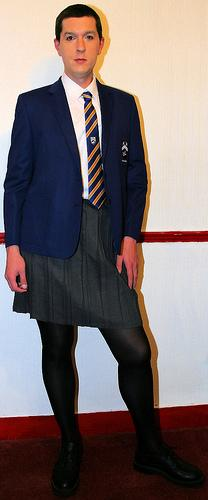Can you describe the color and pattern of the tie the man is wearing? The man is wearing a blue tie with yellow stripes and an emblem on it. What is the color of the background and how does it relate to the man in the image? The background color is light, and the man is standing against the light-colored wall. What is the color of the skirt the man is wearing in the image? The skirt the man is wearing is gray. Count the number of legs visible in the image and provide a brief description of their appearance. There are two legs in the image, they are wearing black nylons. How would you describe the man's hairstyle in the image? The man has short black hair. What type of wall decoration is visible in the image and what is its color? There is red wood on the wall. What type of flooring is visible in the image? There is a maroon carpet on the floor. Analyze the mood of the image based on the colors and objects present. The mood of the image is formal and sophisticated due to the presence of a man dressed in a suit, tie, and skirt, along with the maroon carpet and red wood wall decoration. Identify the hand(s) of the person visible in the image and provide a brief description of their position. The right hand of the man is visible, and it is positioned near the waist. What type of shoes is the person wearing, and what is their color? The person is wearing a pair of black shoes with thick soles and laces. Identify the pattern on the woman's dress. No, it's not mentioned in the image. Focus on the dog lying on the maroon carpet. There is no mention of a dog in the image information. The only reference to the maroon carpet is on the floor, and it does not include any other objects or creatures. Can you locate the green hat on this person's head? There is no mention of a green hat in the list of objects in the image. All references to the person's head specify black short hair, so it is misleading to ask for a green hat. Can you count the number of flowers in the bouquet on the table? There is no mention of a table or a bouquet of flowers in the image information. Any mention of counting flowers or locating a table would be misleading and create confusion. Draw a circle around the cat sitting on the windowsill. There is no mention of a cat or a windowsill in the image information. Therefore, asking to draw a circle around non-existent objects in this image would be misleading. Point out the beautiful scenery depicted in the painting on the light-colored wall. Although there is a reference to a light-colored wall, there is no mention of a painting in the image information. Thus, asking a question about beautiful scenery introduces non-existent objects to the scene. 